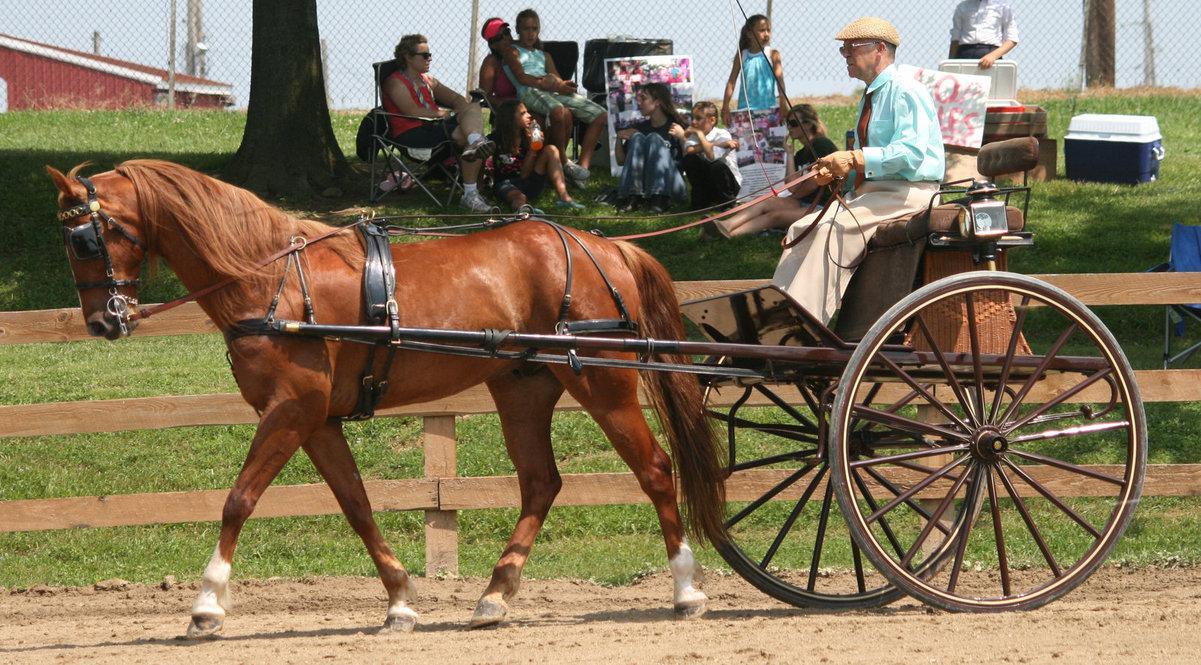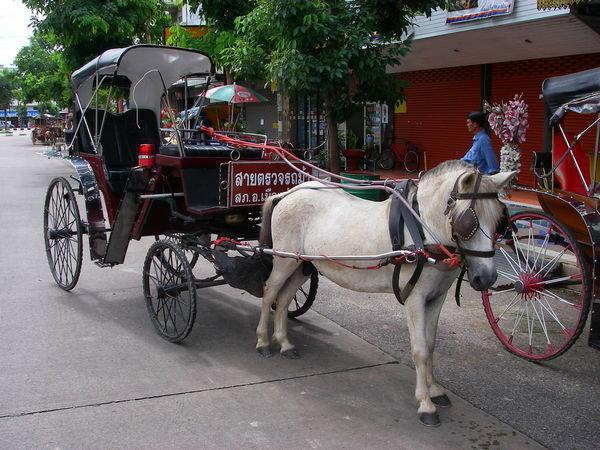The first image is the image on the left, the second image is the image on the right. For the images displayed, is the sentence "At least one horse is white." factually correct? Answer yes or no. Yes. 